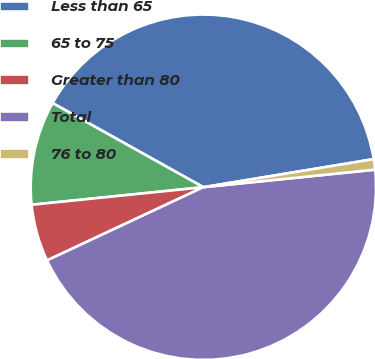<chart> <loc_0><loc_0><loc_500><loc_500><pie_chart><fcel>Less than 65<fcel>65 to 75<fcel>Greater than 80<fcel>Total<fcel>76 to 80<nl><fcel>39.3%<fcel>9.72%<fcel>5.35%<fcel>44.65%<fcel>0.98%<nl></chart> 